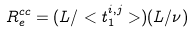<formula> <loc_0><loc_0><loc_500><loc_500>R ^ { c c } _ { e } = ( L / < t ^ { i , j } _ { 1 } > ) ( L / \nu )</formula> 